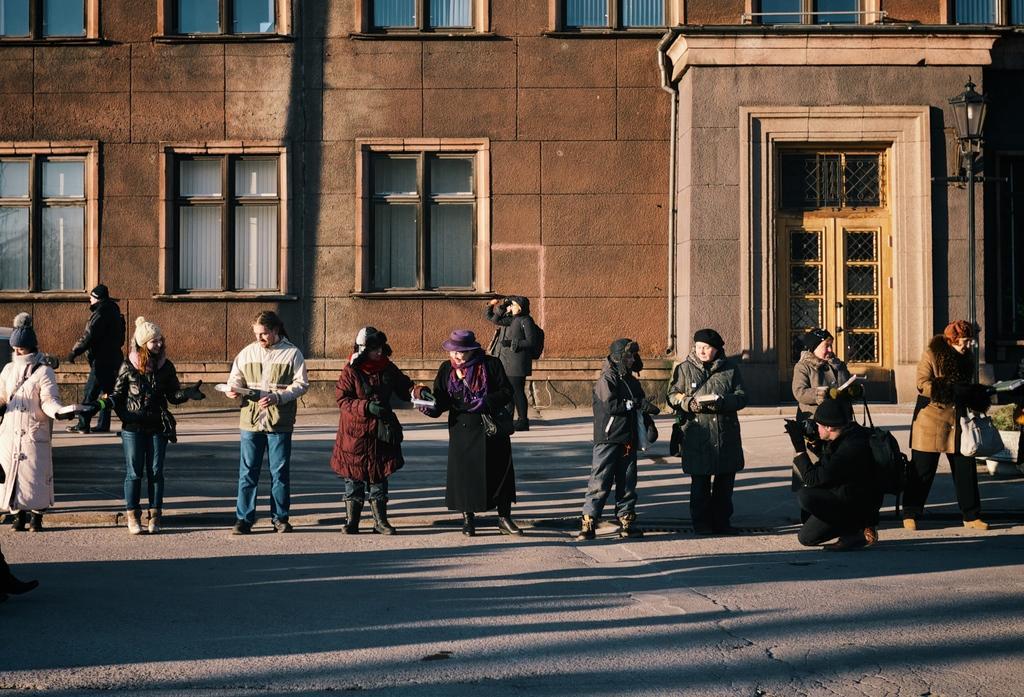Describe this image in one or two sentences. In this image I can see group of people standing on the road, in front the person is wearing black jacket, blue pant. Background I can see few persons walking and holding some object and the building is in brown color and I can see few glass windows. 